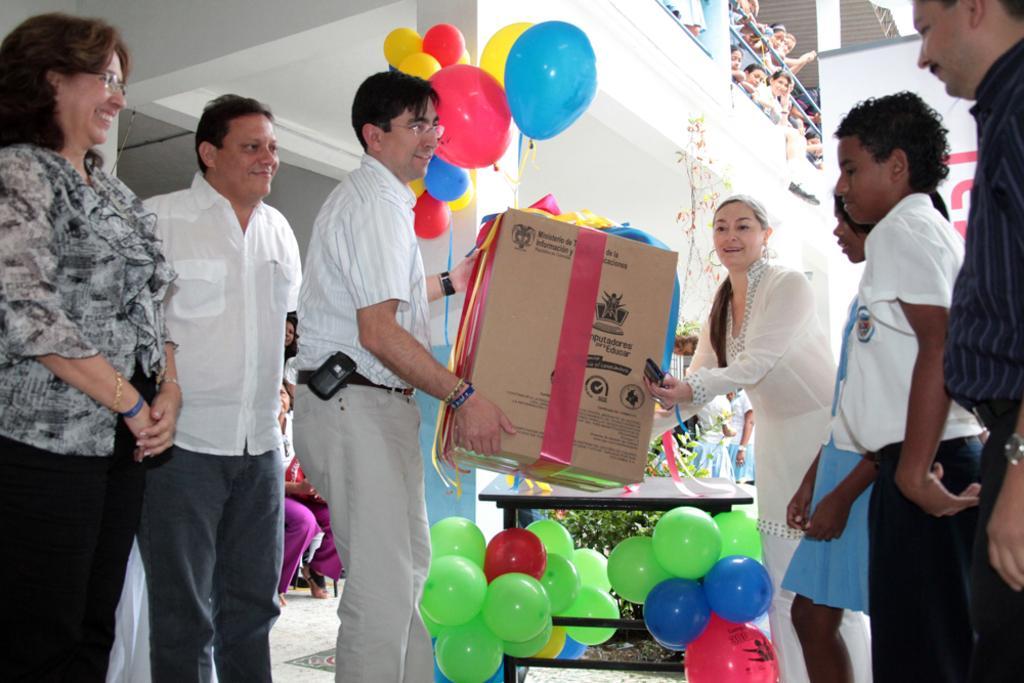Describe this image in one or two sentences. In this picture we can see a group of people standing on the floor and two people are holding a cardboard box. Behind the people there is a table, plant, balloons, pillar and some people are standing in the balcony and a banner. 